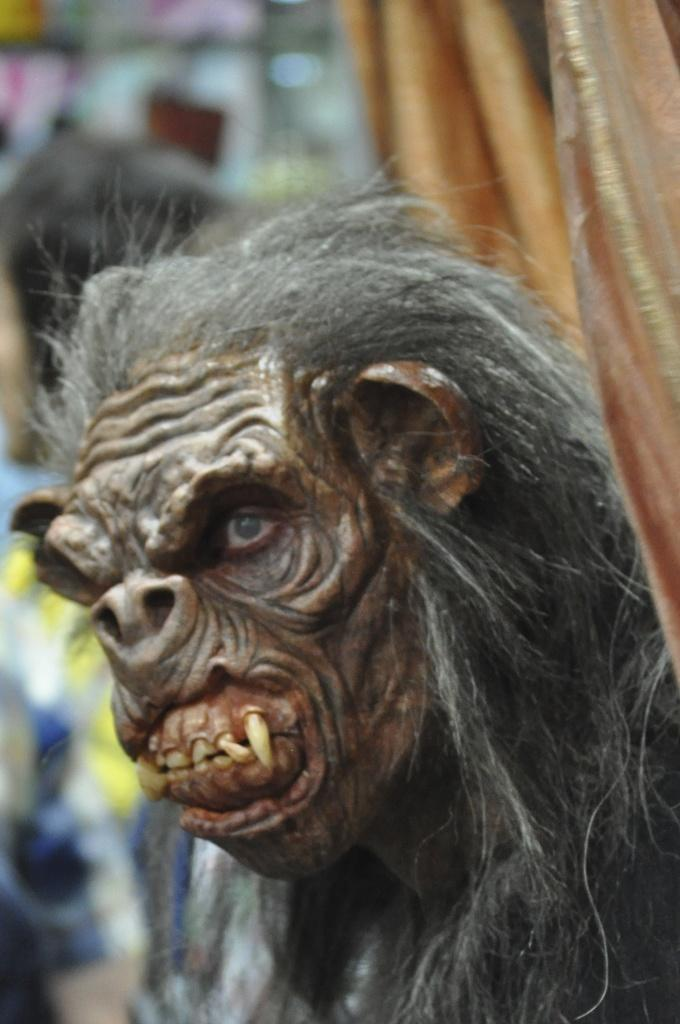What is the main subject of the image? There is a statue of a gorilla in the image. Can you describe the background of the image? The background of the image is blurry. What type of wine is being served at the science conference in the image? There is no wine, science conference, or any indication of a gathering in the image. The image only features a statue of a gorilla with a blurry background. 